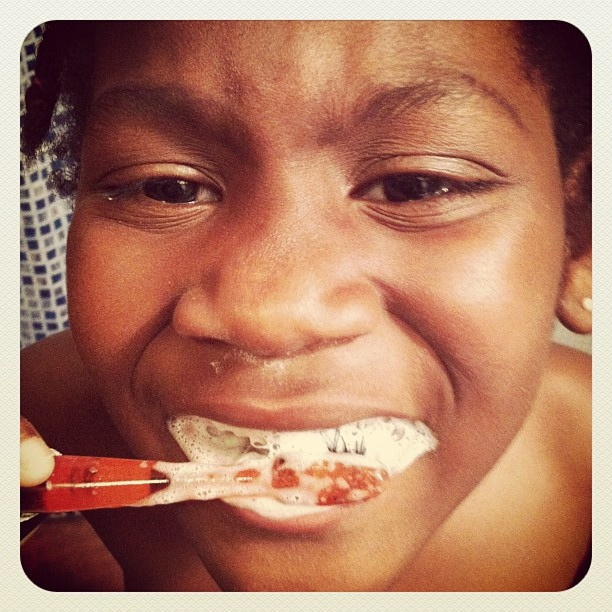Describe the objects in this image and their specific colors. I can see people in ivory, tan, maroon, and brown tones and toothbrush in ivory, tan, brown, and red tones in this image. 